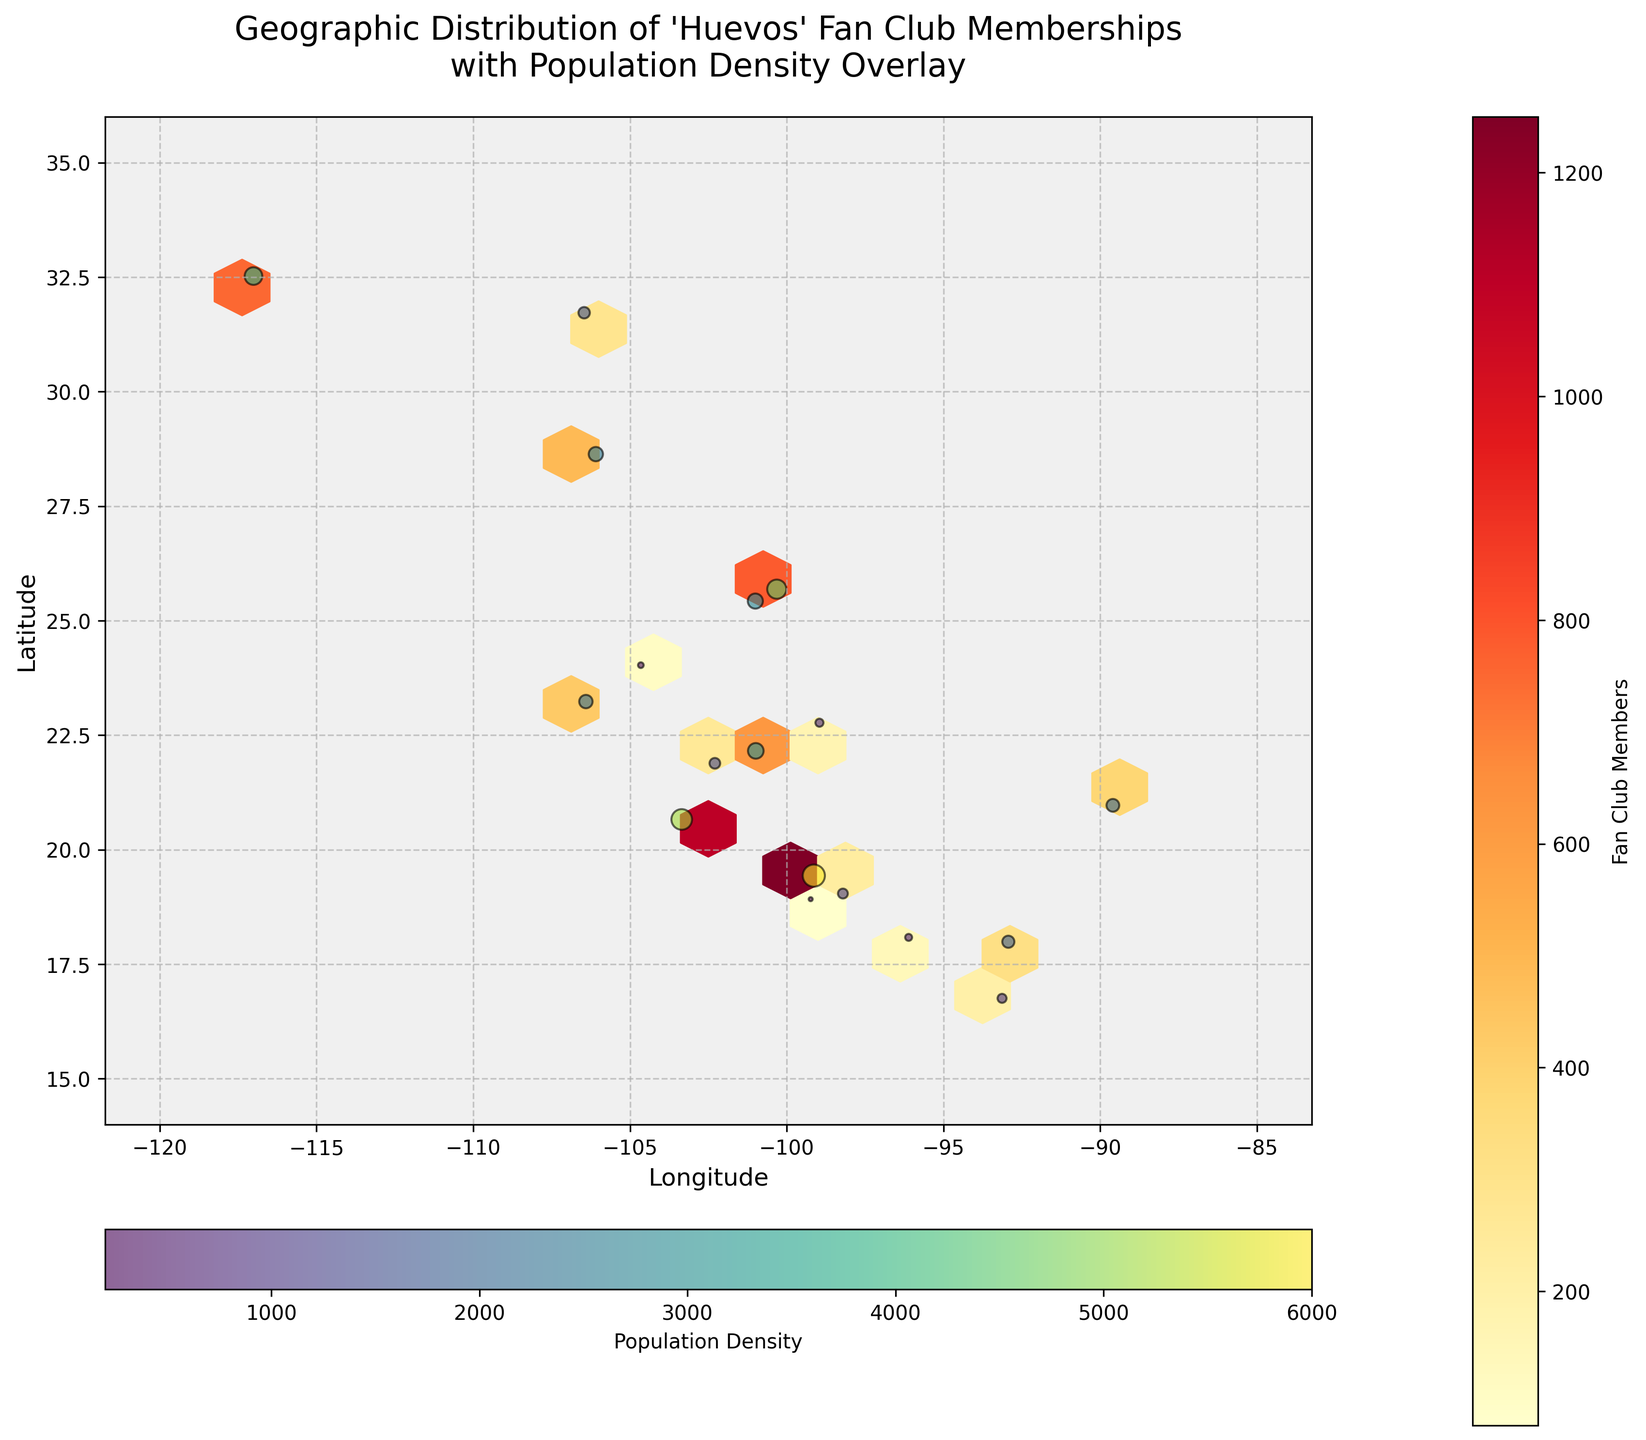What is the title of the plot? The title of the plot is placed at the top of the image. It usually summarizes what the plot represents. In this case, the title reads "Geographic Distribution of 'Huevos' Fan Club Memberships with Population Density Overlay".
Answer: Geographic Distribution of 'Huevos' Fan Club Memberships with Population Density Overlay How are the fan club memberships represented on the plot? Fan club memberships are shown using a hexagonal binning plot with color intensity, where deeper colors indicate higher memberships. There is also a color bar labeled "Fan Club Members" to signify this.
Answer: By color intensity in hexagons What color scheme is used to show population density? The population density is represented using a scatter plot with different shades of color, ranging from light to dark. The color scheme used is 'viridis', and there's a corresponding color bar labeled "Population Density".
Answer: 'viridis' Which latitude and longitude has the highest density of population based on the scatter plot? To determine this, look for the point with the largest scatter marker (indicating higher density) and find its corresponding latitude and longitude from the set of scatter points. The largest dot seems to be around the coordinates 19.4326, -99.1332.
Answer: 19.4326, -99.1332 What is the population density at longitude 18.9185 and latitude -99.2343? Locate the scatter point at 18.9185 latitude and -99.2343 longitude. Notice its color, and compare this with the horizontal color bar for population density. This point is shown with the lightest color, indicating a population density of 200.
Answer: 200 Among the fan club memberships, which city appears to have the highest membership, based on the hexbin color intensity? Look for the hexagon with the most intense color (deepest red), which maps to the highest value on the vertical "Fan Club Members" color bar. This is centered around 19.4326 latitude and -99.1332 longitude, corresponding to the location with a membership value of 1250.
Answer: 19.4326, -99.1332 (Mexico City) Compare the fan club membership between latitude 22.1565 and longitude -100.9855 with latitude 31.7219 and longitude -106.4613. Which one is higher? To answer this, check the color intensity of the hexagons at the listed coordinates. The first pair (22.1565, -100.9855) has a deeper color compared to the second pair (31.7219, -106.4613), indicating higher membership. By referring to the data, memberships are 620 and 290, respectively.
Answer: Latitude 22.1565 and Longitude -100.9855 What is the average population density for the cities with fan club memberships greater than 300? Select cities with memberships greater than 300: (1250, 980, 1100, 750, 620, 580, 490, 430, 380). Their population densities are (6000, 4500, 5200, 3800, 3000, 2800, 2500, 2200, 2000). Compute the average: sum these values (6000 + 4500 + 5200 + 3800 + 3000 + 2800 + 2500 + 2200 + 2000 = 32000), then divide by the number of cities (9). 32000 / 9 = 3555.
Answer: 3555 What are the longitude and latitude ranges of the plot? Check the x-axis and y-axis labels for ranges. The longitude extends from -120 to -85, and the latitude ranges from 15 to 35. These ranges set the geographic bounds of the plot.
Answer: Longitude: -120 to -85, Latitude: 15 to 35 Which city has the smallest population density and what is its corresponding fan club membership number? Locate the smallest marker on the scatter plot, and refer to its color compared to the population density color bar. The smallest value is located at 18.9185 latitude, -99.2343 longitude with a population density of 200 and a fan club membership of 80.
Answer: 18.9185, -99.2343 with 80 members 